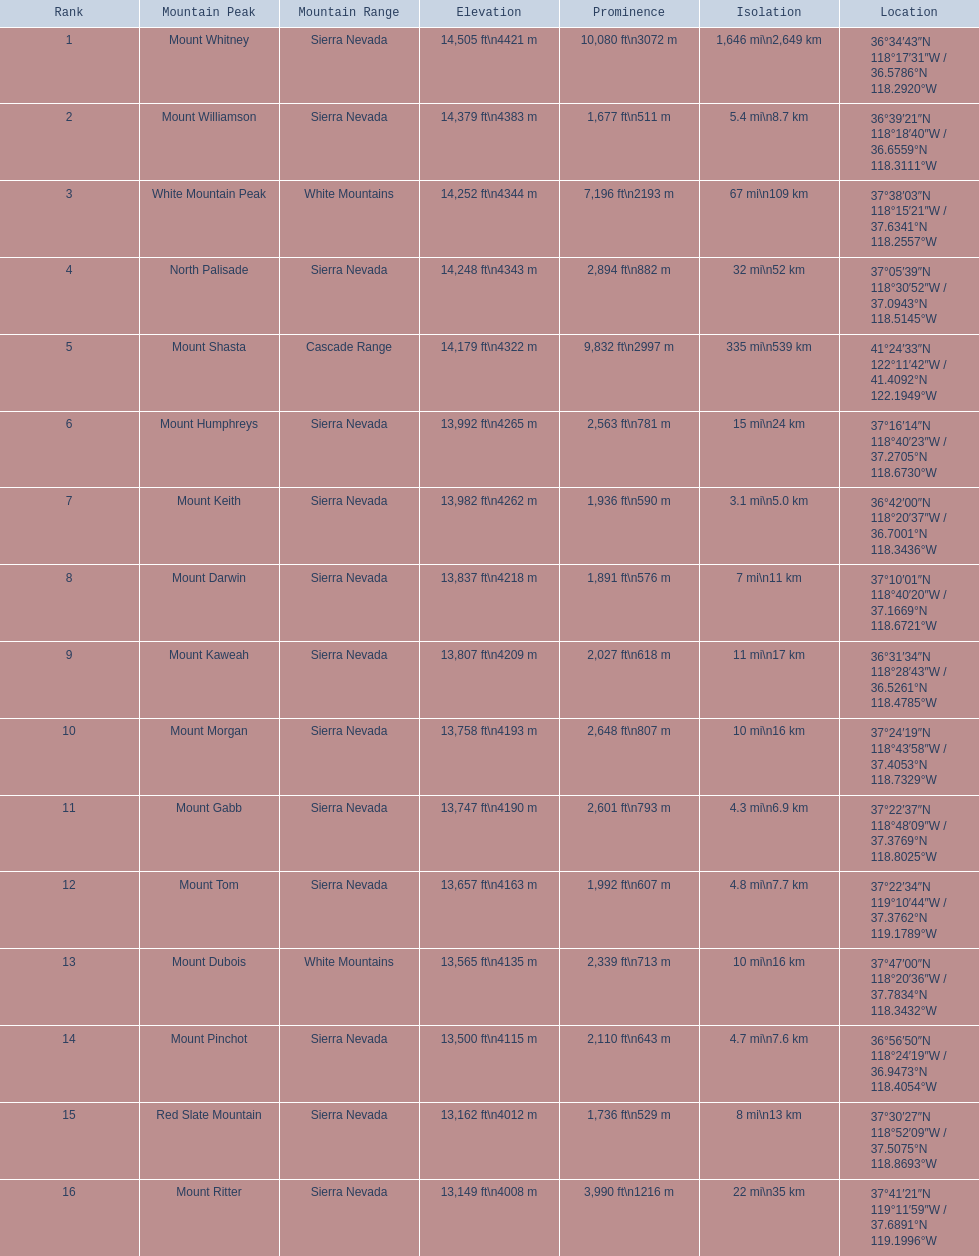What are all the apexes? Mount Whitney, Mount Williamson, White Mountain Peak, North Palisade, Mount Shasta, Mount Humphreys, Mount Keith, Mount Darwin, Mount Kaweah, Mount Morgan, Mount Gabb, Mount Tom, Mount Dubois, Mount Pinchot, Red Slate Mountain, Mount Ritter. Where are they positioned? Sierra Nevada, Sierra Nevada, White Mountains, Sierra Nevada, Cascade Range, Sierra Nevada, Sierra Nevada, Sierra Nevada, Sierra Nevada, Sierra Nevada, Sierra Nevada, Sierra Nevada, White Mountains, Sierra Nevada, Sierra Nevada, Sierra Nevada. How tall are they? 14,505 ft\n4421 m, 14,379 ft\n4383 m, 14,252 ft\n4344 m, 14,248 ft\n4343 m, 14,179 ft\n4322 m, 13,992 ft\n4265 m, 13,982 ft\n4262 m, 13,837 ft\n4218 m, 13,807 ft\n4209 m, 13,758 ft\n4193 m, 13,747 ft\n4190 m, 13,657 ft\n4163 m, 13,565 ft\n4135 m, 13,500 ft\n4115 m, 13,162 ft\n4012 m, 13,149 ft\n4008 m. What about merely the apexes in the sierra nevadas? 14,505 ft\n4421 m, 14,379 ft\n4383 m, 14,248 ft\n4343 m, 13,992 ft\n4265 m, 13,982 ft\n4262 m, 13,837 ft\n4218 m, 13,807 ft\n4209 m, 13,758 ft\n4193 m, 13,747 ft\n4190 m, 13,657 ft\n4163 m, 13,500 ft\n4115 m, 13,162 ft\n4012 m, 13,149 ft\n4008 m. And of those, which is the most elevated? Mount Whitney. 